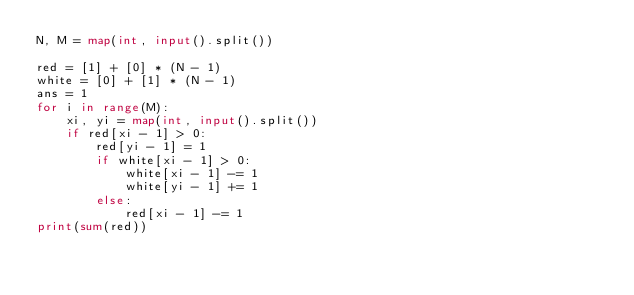Convert code to text. <code><loc_0><loc_0><loc_500><loc_500><_Python_>N, M = map(int, input().split())

red = [1] + [0] * (N - 1)
white = [0] + [1] * (N - 1)
ans = 1
for i in range(M):
    xi, yi = map(int, input().split())
    if red[xi - 1] > 0:
        red[yi - 1] = 1
        if white[xi - 1] > 0:
            white[xi - 1] -= 1
            white[yi - 1] += 1
        else:
            red[xi - 1] -= 1
print(sum(red))
</code> 